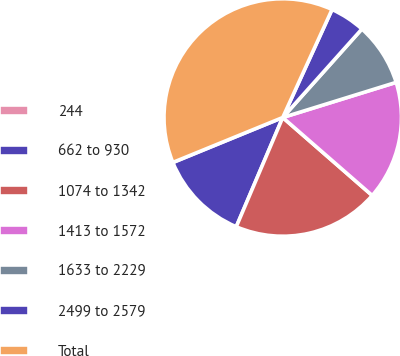<chart> <loc_0><loc_0><loc_500><loc_500><pie_chart><fcel>244<fcel>662 to 930<fcel>1074 to 1342<fcel>1413 to 1572<fcel>1633 to 2229<fcel>2499 to 2579<fcel>Total<nl><fcel>0.02%<fcel>12.4%<fcel>19.99%<fcel>16.19%<fcel>8.6%<fcel>4.8%<fcel>37.99%<nl></chart> 